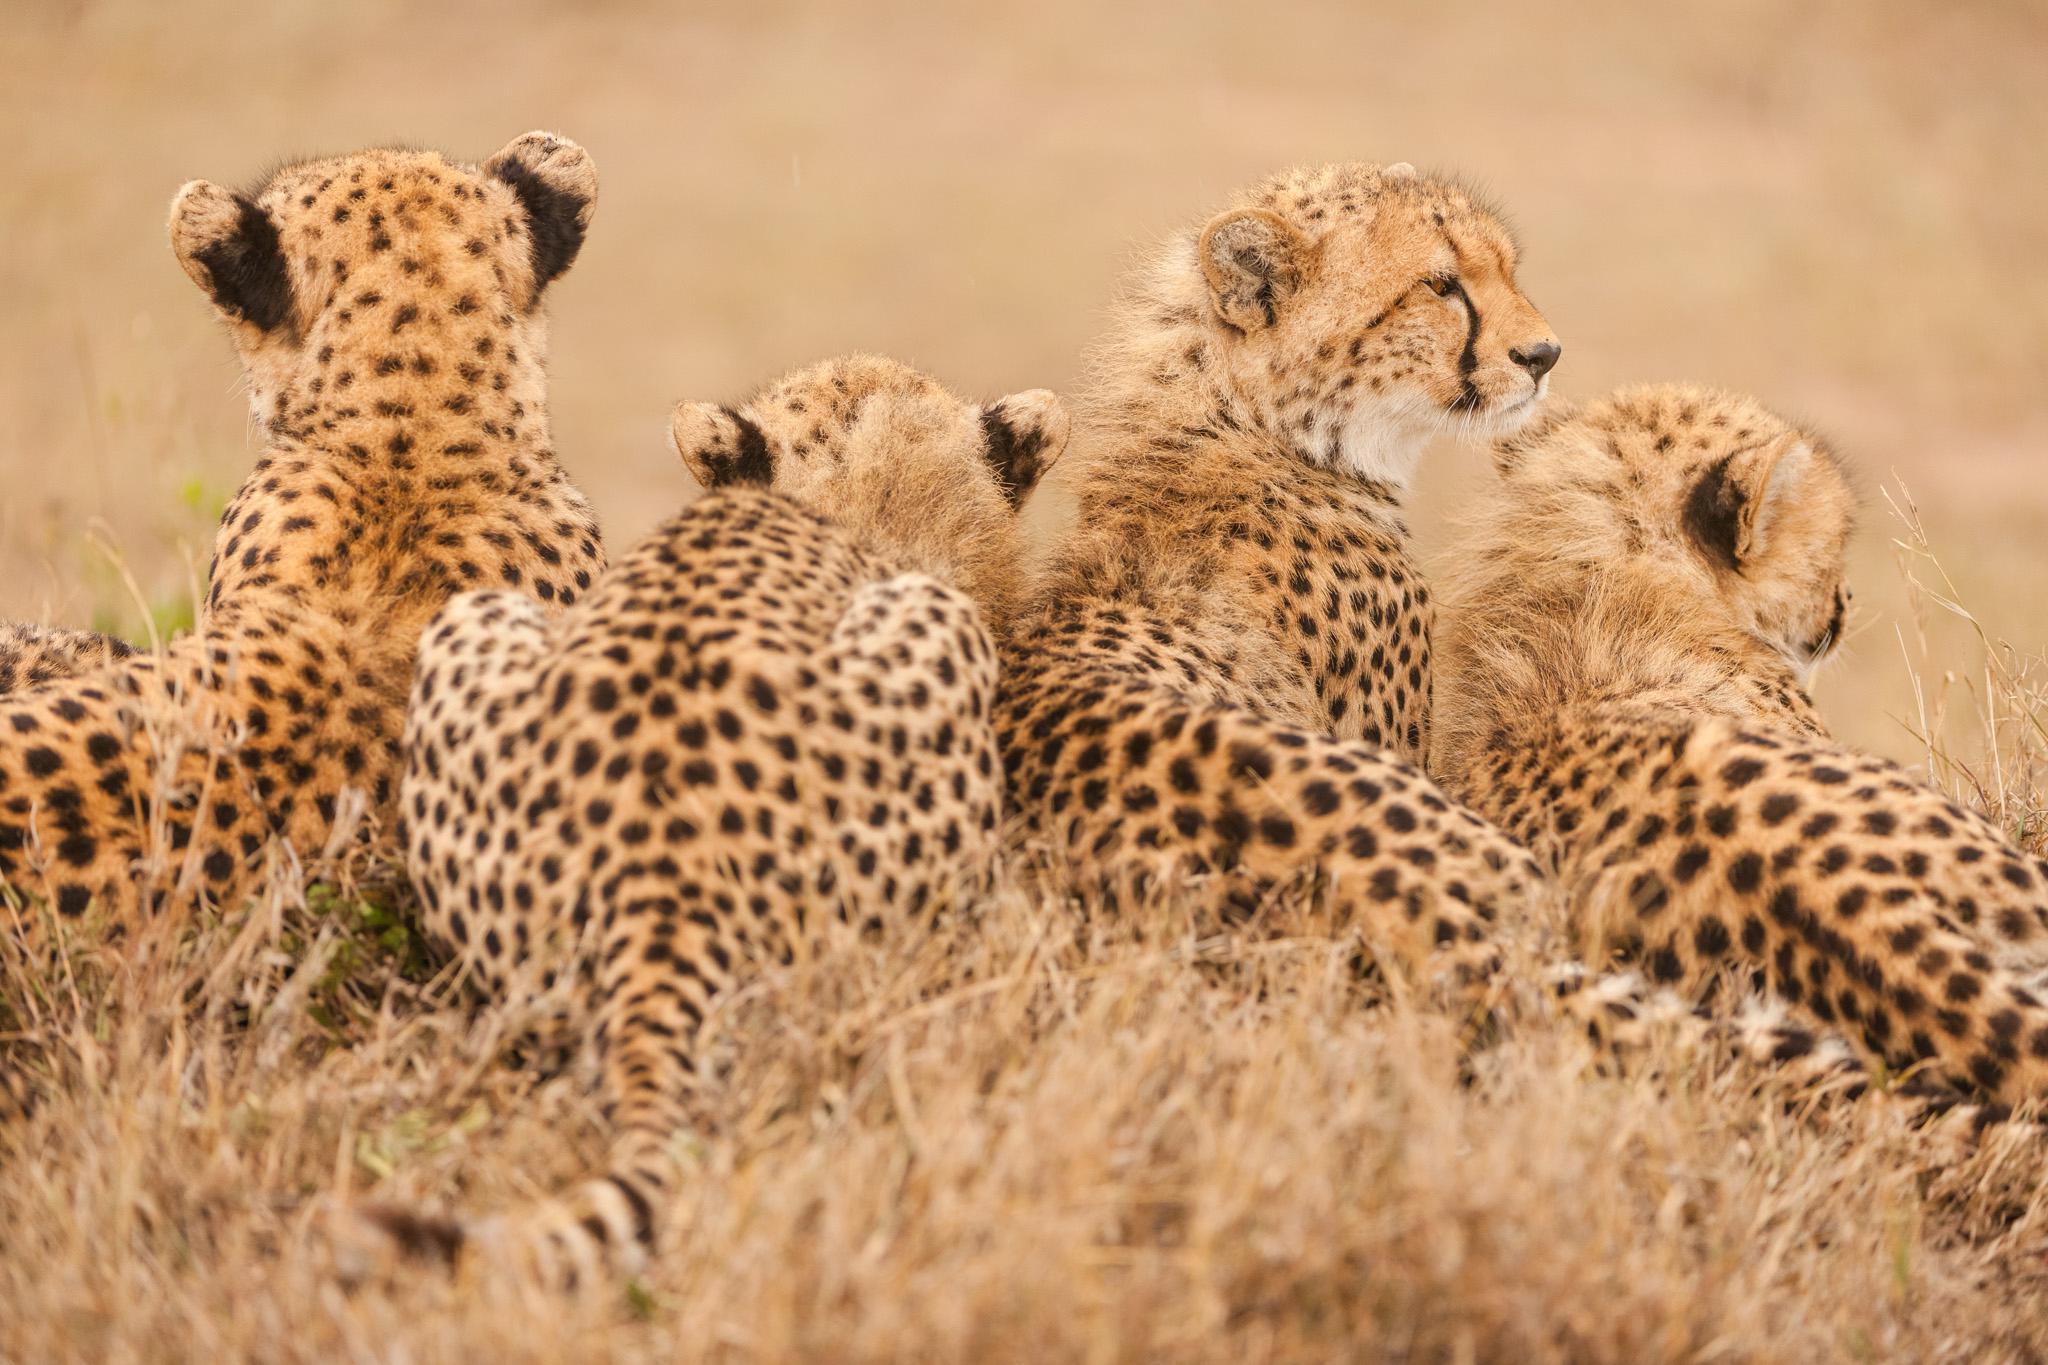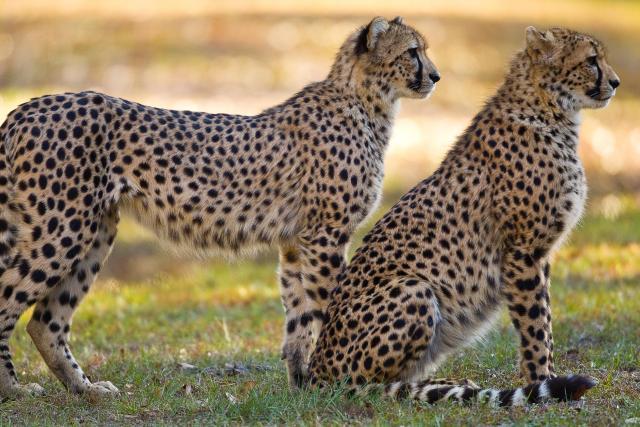The first image is the image on the left, the second image is the image on the right. Evaluate the accuracy of this statement regarding the images: "There are a total of 6 or more wild cats.". Is it true? Answer yes or no. Yes. The first image is the image on the left, the second image is the image on the right. For the images displayed, is the sentence "An image shows one wild cat with its mouth and paw on the other wild cat." factually correct? Answer yes or no. No. 